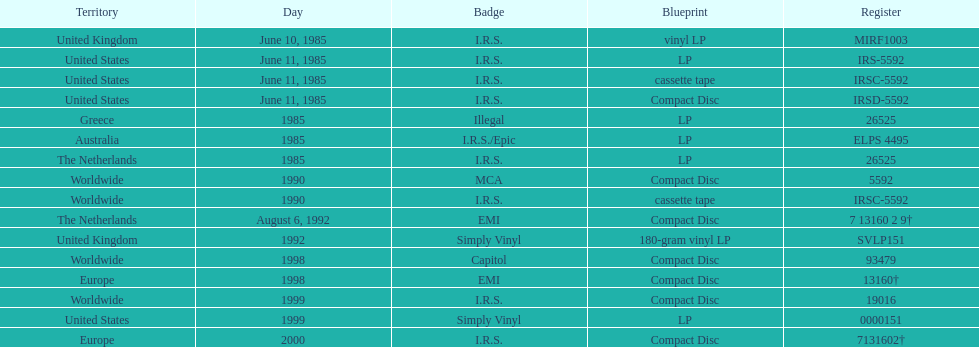Which country or region had the most releases? Worldwide. 